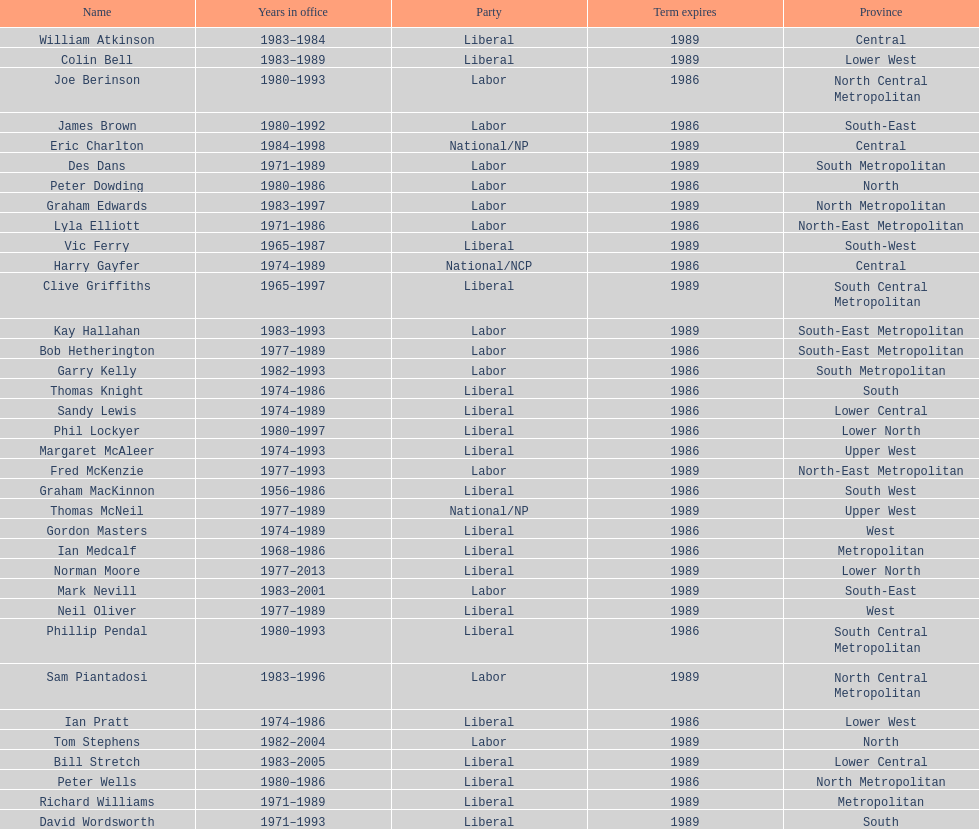Which party has the most membership? Liberal. Would you mind parsing the complete table? {'header': ['Name', 'Years in office', 'Party', 'Term expires', 'Province'], 'rows': [['William Atkinson', '1983–1984', 'Liberal', '1989', 'Central'], ['Colin Bell', '1983–1989', 'Liberal', '1989', 'Lower West'], ['Joe Berinson', '1980–1993', 'Labor', '1986', 'North Central Metropolitan'], ['James Brown', '1980–1992', 'Labor', '1986', 'South-East'], ['Eric Charlton', '1984–1998', 'National/NP', '1989', 'Central'], ['Des Dans', '1971–1989', 'Labor', '1989', 'South Metropolitan'], ['Peter Dowding', '1980–1986', 'Labor', '1986', 'North'], ['Graham Edwards', '1983–1997', 'Labor', '1989', 'North Metropolitan'], ['Lyla Elliott', '1971–1986', 'Labor', '1986', 'North-East Metropolitan'], ['Vic Ferry', '1965–1987', 'Liberal', '1989', 'South-West'], ['Harry Gayfer', '1974–1989', 'National/NCP', '1986', 'Central'], ['Clive Griffiths', '1965–1997', 'Liberal', '1989', 'South Central Metropolitan'], ['Kay Hallahan', '1983–1993', 'Labor', '1989', 'South-East Metropolitan'], ['Bob Hetherington', '1977–1989', 'Labor', '1986', 'South-East Metropolitan'], ['Garry Kelly', '1982–1993', 'Labor', '1986', 'South Metropolitan'], ['Thomas Knight', '1974–1986', 'Liberal', '1986', 'South'], ['Sandy Lewis', '1974–1989', 'Liberal', '1986', 'Lower Central'], ['Phil Lockyer', '1980–1997', 'Liberal', '1986', 'Lower North'], ['Margaret McAleer', '1974–1993', 'Liberal', '1986', 'Upper West'], ['Fred McKenzie', '1977–1993', 'Labor', '1989', 'North-East Metropolitan'], ['Graham MacKinnon', '1956–1986', 'Liberal', '1986', 'South West'], ['Thomas McNeil', '1977–1989', 'National/NP', '1989', 'Upper West'], ['Gordon Masters', '1974–1989', 'Liberal', '1986', 'West'], ['Ian Medcalf', '1968–1986', 'Liberal', '1986', 'Metropolitan'], ['Norman Moore', '1977–2013', 'Liberal', '1989', 'Lower North'], ['Mark Nevill', '1983–2001', 'Labor', '1989', 'South-East'], ['Neil Oliver', '1977–1989', 'Liberal', '1989', 'West'], ['Phillip Pendal', '1980–1993', 'Liberal', '1986', 'South Central Metropolitan'], ['Sam Piantadosi', '1983–1996', 'Labor', '1989', 'North Central Metropolitan'], ['Ian Pratt', '1974–1986', 'Liberal', '1986', 'Lower West'], ['Tom Stephens', '1982–2004', 'Labor', '1989', 'North'], ['Bill Stretch', '1983–2005', 'Liberal', '1989', 'Lower Central'], ['Peter Wells', '1980–1986', 'Liberal', '1986', 'North Metropolitan'], ['Richard Williams', '1971–1989', 'Liberal', '1989', 'Metropolitan'], ['David Wordsworth', '1971–1993', 'Liberal', '1989', 'South']]} 